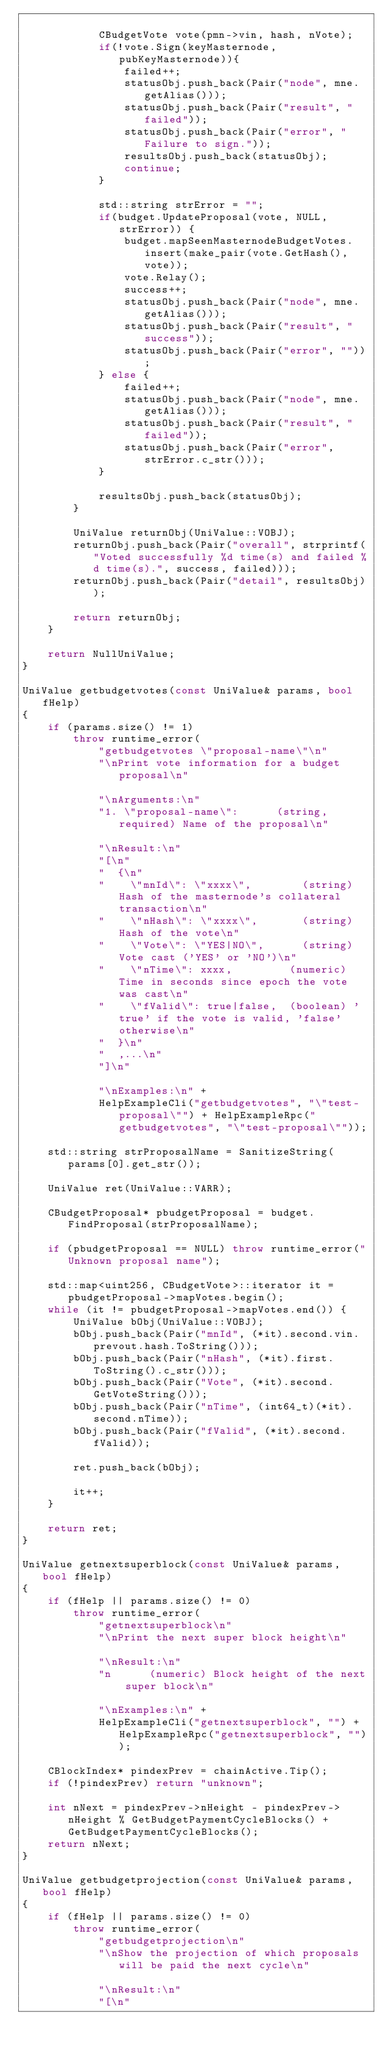Convert code to text. <code><loc_0><loc_0><loc_500><loc_500><_C++_>
            CBudgetVote vote(pmn->vin, hash, nVote);
            if(!vote.Sign(keyMasternode, pubKeyMasternode)){
                failed++;
                statusObj.push_back(Pair("node", mne.getAlias()));
                statusObj.push_back(Pair("result", "failed"));
                statusObj.push_back(Pair("error", "Failure to sign."));
                resultsObj.push_back(statusObj);
                continue;
            }

            std::string strError = "";
            if(budget.UpdateProposal(vote, NULL, strError)) {
                budget.mapSeenMasternodeBudgetVotes.insert(make_pair(vote.GetHash(), vote));
                vote.Relay();
                success++;
                statusObj.push_back(Pair("node", mne.getAlias()));
                statusObj.push_back(Pair("result", "success"));
                statusObj.push_back(Pair("error", ""));
            } else {
                failed++;
                statusObj.push_back(Pair("node", mne.getAlias()));
                statusObj.push_back(Pair("result", "failed"));
                statusObj.push_back(Pair("error", strError.c_str()));
            }

            resultsObj.push_back(statusObj);
        }

        UniValue returnObj(UniValue::VOBJ);
        returnObj.push_back(Pair("overall", strprintf("Voted successfully %d time(s) and failed %d time(s).", success, failed)));
        returnObj.push_back(Pair("detail", resultsObj));

        return returnObj;
    }

    return NullUniValue;
}

UniValue getbudgetvotes(const UniValue& params, bool fHelp)
{
    if (params.size() != 1)
        throw runtime_error(
            "getbudgetvotes \"proposal-name\"\n"
            "\nPrint vote information for a budget proposal\n"

            "\nArguments:\n"
            "1. \"proposal-name\":      (string, required) Name of the proposal\n"

            "\nResult:\n"
            "[\n"
            "  {\n"
            "    \"mnId\": \"xxxx\",        (string) Hash of the masternode's collateral transaction\n"
            "    \"nHash\": \"xxxx\",       (string) Hash of the vote\n"
            "    \"Vote\": \"YES|NO\",      (string) Vote cast ('YES' or 'NO')\n"
            "    \"nTime\": xxxx,         (numeric) Time in seconds since epoch the vote was cast\n"
            "    \"fValid\": true|false,  (boolean) 'true' if the vote is valid, 'false' otherwise\n"
            "  }\n"
            "  ,...\n"
            "]\n"

            "\nExamples:\n" +
            HelpExampleCli("getbudgetvotes", "\"test-proposal\"") + HelpExampleRpc("getbudgetvotes", "\"test-proposal\""));

    std::string strProposalName = SanitizeString(params[0].get_str());

    UniValue ret(UniValue::VARR);

    CBudgetProposal* pbudgetProposal = budget.FindProposal(strProposalName);

    if (pbudgetProposal == NULL) throw runtime_error("Unknown proposal name");

    std::map<uint256, CBudgetVote>::iterator it = pbudgetProposal->mapVotes.begin();
    while (it != pbudgetProposal->mapVotes.end()) {
        UniValue bObj(UniValue::VOBJ);
        bObj.push_back(Pair("mnId", (*it).second.vin.prevout.hash.ToString()));
        bObj.push_back(Pair("nHash", (*it).first.ToString().c_str()));
        bObj.push_back(Pair("Vote", (*it).second.GetVoteString()));
        bObj.push_back(Pair("nTime", (int64_t)(*it).second.nTime));
        bObj.push_back(Pair("fValid", (*it).second.fValid));

        ret.push_back(bObj);

        it++;
    }

    return ret;
}

UniValue getnextsuperblock(const UniValue& params, bool fHelp)
{
    if (fHelp || params.size() != 0)
        throw runtime_error(
            "getnextsuperblock\n"
            "\nPrint the next super block height\n"

            "\nResult:\n"
            "n      (numeric) Block height of the next super block\n"

            "\nExamples:\n" +
            HelpExampleCli("getnextsuperblock", "") + HelpExampleRpc("getnextsuperblock", ""));

    CBlockIndex* pindexPrev = chainActive.Tip();
    if (!pindexPrev) return "unknown";

    int nNext = pindexPrev->nHeight - pindexPrev->nHeight % GetBudgetPaymentCycleBlocks() + GetBudgetPaymentCycleBlocks();
    return nNext;
}

UniValue getbudgetprojection(const UniValue& params, bool fHelp)
{
    if (fHelp || params.size() != 0)
        throw runtime_error(
            "getbudgetprojection\n"
            "\nShow the projection of which proposals will be paid the next cycle\n"

            "\nResult:\n"
            "[\n"</code> 